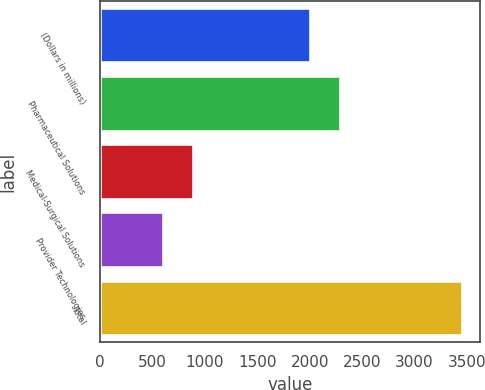Convert chart to OTSL. <chart><loc_0><loc_0><loc_500><loc_500><bar_chart><fcel>(Dollars in millions)<fcel>Pharmaceutical Solutions<fcel>Medical-Surgical Solutions<fcel>Provider Technologies<fcel>Total<nl><fcel>2005<fcel>2289.2<fcel>892.2<fcel>608<fcel>3450<nl></chart> 